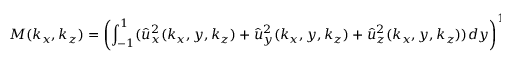<formula> <loc_0><loc_0><loc_500><loc_500>M ( k _ { x } , k _ { z } ) = \left ( \int _ { - 1 } ^ { 1 } ( \hat { u } _ { x } ^ { 2 } ( k _ { x } , y , k _ { z } ) + \hat { u } _ { y } ^ { 2 } ( k _ { x } , y , k _ { z } ) + \hat { u } _ { z } ^ { 2 } ( k _ { x } , y , k _ { z } ) ) d y \right ) ^ { 1 / 2 } ,</formula> 